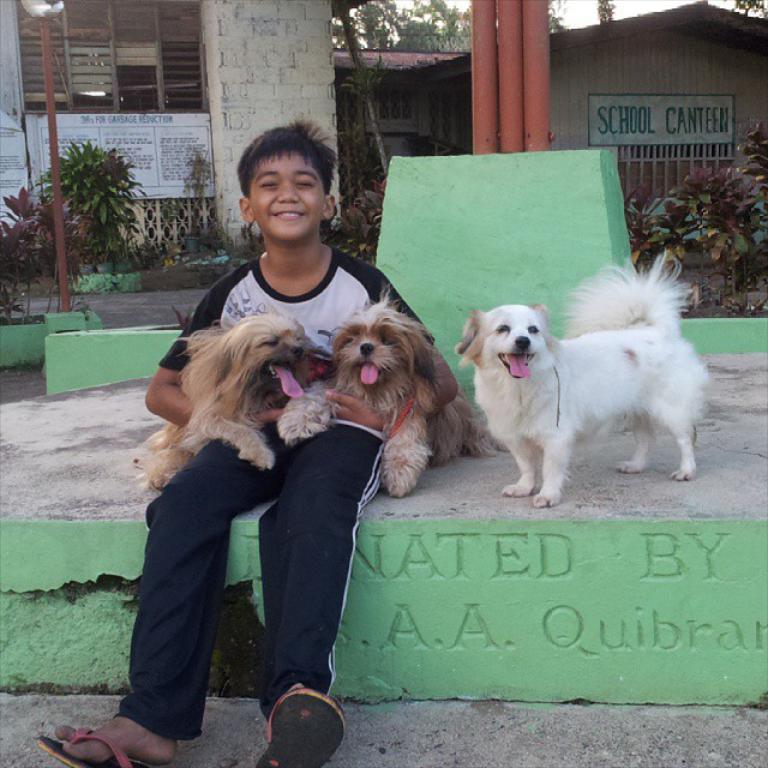How would you summarize this image in a sentence or two? In this picture there is a boy who is wearing t-shirt, trouser and sleeper. He is holding two brown puppy, beside him there is a white puppy which is standing near to the wall. In the background I can see the trees, plants, grass, poles, shed and building. In the top right corner I can see the sky. 